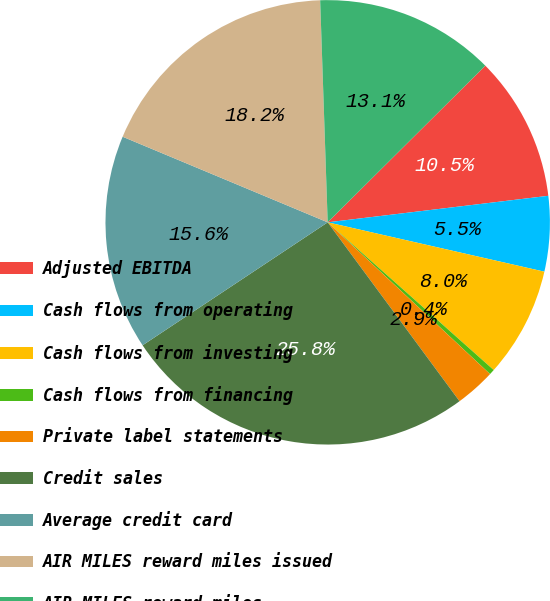Convert chart to OTSL. <chart><loc_0><loc_0><loc_500><loc_500><pie_chart><fcel>Adjusted EBITDA<fcel>Cash flows from operating<fcel>Cash flows from investing<fcel>Cash flows from financing<fcel>Private label statements<fcel>Credit sales<fcel>Average credit card<fcel>AIR MILES reward miles issued<fcel>AIR MILES reward miles<nl><fcel>10.55%<fcel>5.47%<fcel>8.01%<fcel>0.39%<fcel>2.93%<fcel>25.78%<fcel>15.63%<fcel>18.17%<fcel>13.09%<nl></chart> 